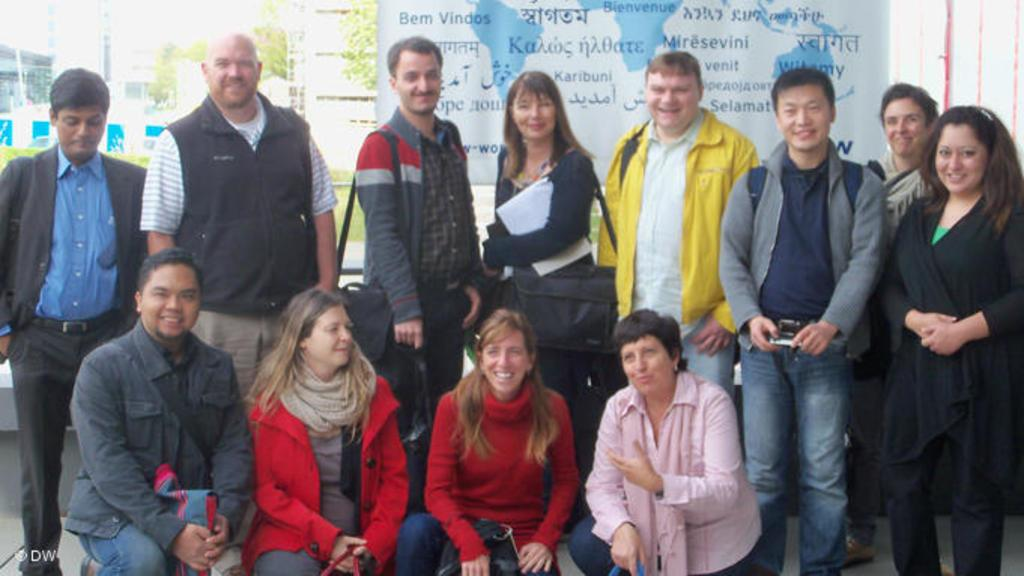What are the people in the foreground of the image doing? The people in the foreground of the image are posing for a camera. Can you describe the clothing or accessories of the people in the image? Two of the people are wearing bags. What can be seen in the background of the image? There is a banner, trees, and buildings in the background of the image. What type of salt is being used to season the food at the party in the image? There is no party or food present in the image, and therefore no salt can be observed. Can you tell me the name of the partner of the person standing next to the banner in the image? There is no partner or person standing next to the banner in the image; only the banner itself is visible. 